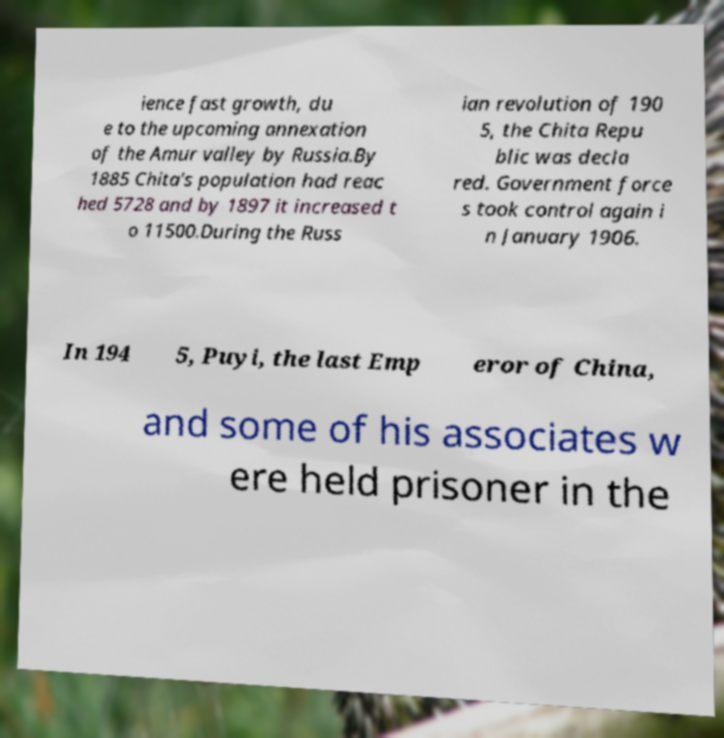I need the written content from this picture converted into text. Can you do that? ience fast growth, du e to the upcoming annexation of the Amur valley by Russia.By 1885 Chita's population had reac hed 5728 and by 1897 it increased t o 11500.During the Russ ian revolution of 190 5, the Chita Repu blic was decla red. Government force s took control again i n January 1906. In 194 5, Puyi, the last Emp eror of China, and some of his associates w ere held prisoner in the 